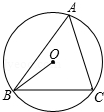Could you examine how the length of arc BC might be determined using the angles provided in the circle? To calculate the length of arc BC, you will first need the radius of the circle and the angle OBC, which we've established is 100 degrees. The length of an arc 'l' can be determined by the formula l = r * theta, where theta is the angle in radians. Converting 100 degrees to radians by multiplying by pi/180 gives approximately 1.745 radians. Therefore, the arc length l equals r times 1.745. 